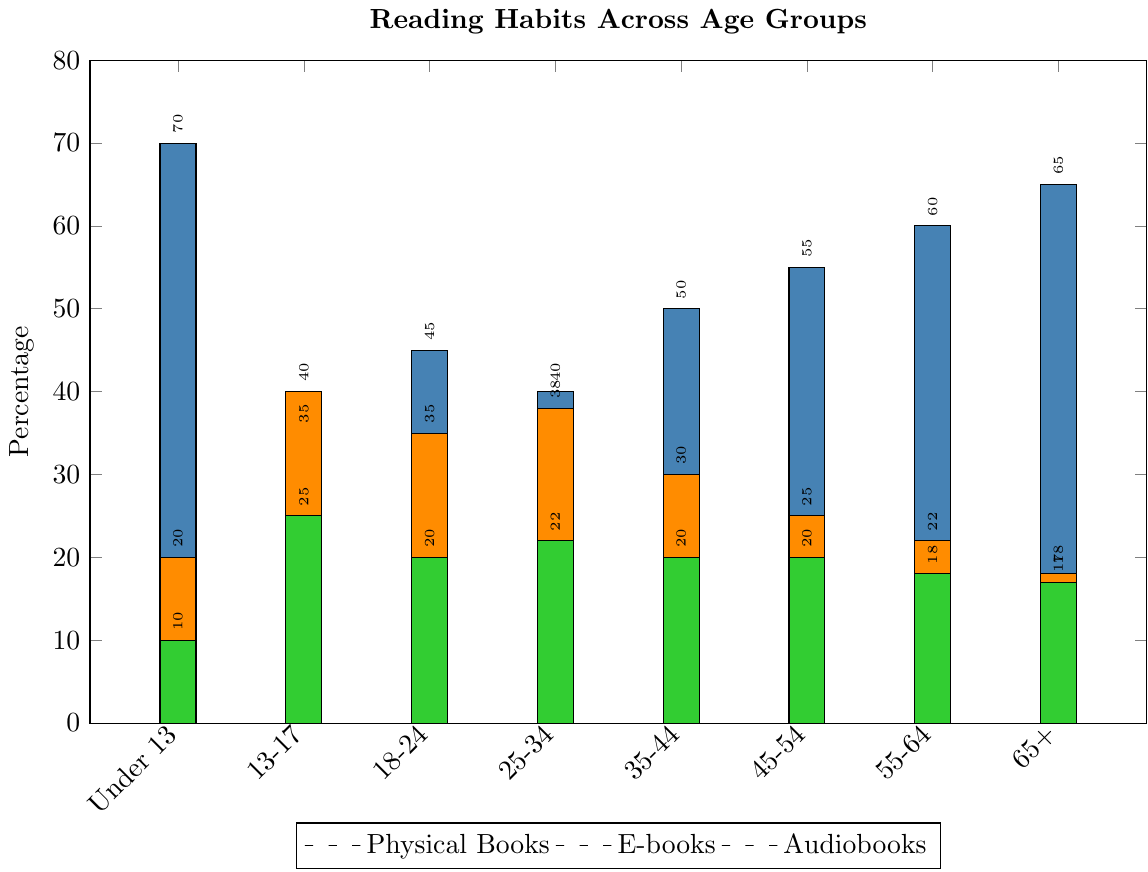Which age group reads the highest percentage of physical books? Look at the bars representing physical books for each age group. Observe that the tallest bar is for the age group "Under 13".
Answer: Under 13 Among 18-24 and 25-34 age groups, which one has a higher percentage of e-book readers? Compare the heights of the bars for e-books between the "18-24" and "25-34" age groups. Notice that the "25-34" bar is slightly taller.
Answer: 25-34 What is the total percentage of audiobook listeners for the age groups 45-54, 55-64, and 65+? Add the percentages of the audiobook listeners in the age groups "45-54" (20), "55-64" (18), and "65+" (17). So, 20 + 18 + 17 = 55.
Answer: 55 Which media type shows a clear decrease in usage with increasing age? Observe the trend of the bars for each media type across the age groups from "Under 13" to "65+". Notice that the audiobook bars show a steady decrease.
Answer: Audiobooks Does any age group read more e-books than physical books? Check each age group’s e-book and physical book bars and see if any age group has a taller e-book bar compared to its physical book bar. The age group "13-17" has a taller bar for e-books (40) than for physical books (35).
Answer: 13-17 What is the average percentage of physical book readers across all age groups? Sum the percentages of physical book readers for each age group: 70 + 35 + 45 + 40 + 50 + 55 + 60 + 65 = 420. There are 8 age groups, so 420 / 8 = 52.5.
Answer: 52.5 Which age group has the smallest percentage of audiobook listeners? Look at the bars representing audiobooks and find the shortest one, which belongs to the "Under 13" age group.
Answer: Under 13 Between the age groups 35-44 and 55-64, which one has a higher percentage of readers of physical books? Compare the bars representing physical books for the "35-44" and "55-64" age groups. Notice that the "55-64" bar is taller.
Answer: 55-64 How does the popularity of e-books compare between the youngest and the oldest age groups? Compare the heights of the e-book bars for "Under 13" and "65+" age groups. Notice that the bar for "Under 13" (20) is taller than that for "65+" (18).
Answer: E-books are slightly more popular for "Under 13" than "65+" What is the difference in percentage points between physical book readers and audiobook listeners for the age group 18-24? Look at the bars for the age group "18-24": physical books (45) and audiobooks (20). The difference is 45 - 20 = 25 percentage points.
Answer: 25 